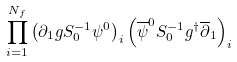<formula> <loc_0><loc_0><loc_500><loc_500>\prod _ { i = 1 } ^ { N _ { f } } \left ( \partial _ { 1 } g S _ { 0 } ^ { - 1 } \psi ^ { 0 } \right ) _ { i } \left ( \overline { \psi } ^ { 0 } S _ { 0 } ^ { - 1 } g ^ { \dag } \overline { \partial } _ { 1 } \right ) _ { i }</formula> 